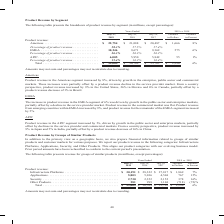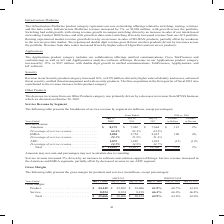From Cisco Systems's financial document, Which categories does the company report its product revenue? The document contains multiple relevant values: Infrastructure Platforms, Applications, Security, Other Products. From the document: "our product revenue in the following categories: Infrastructure Platforms, Applications, Security, and Other Products. This aligns our product categor..." Also, What was the revenue from Security in 2019? According to the financial document, 2,730 (in millions). The relevant text states: "plications . 5,803 5,036 4,568 767 15% Security . 2,730 2,352 2,152 378 16% Other Products . 281 999 1,168 (718) (72)% Total . $ 39,005 $ 36,709 $ 35,705 $..." Also, What was the revenue from Other products in 2018? According to the financial document, 999 (in millions). The relevant text states: ". 2,730 2,352 2,152 378 16% Other Products . 281 999 1,168 (718) (72)% Total . $ 39,005 $ 36,709 $ 35,705 $ 2,296 6%..." Also, can you calculate: What was the change in revenue from security between 2017 and 2018? Based on the calculation: 2,352-2,152, the result is 200 (in millions). This is based on the information: "5,803 5,036 4,568 767 15% Security . 2,730 2,352 2,152 378 16% Other Products . 281 999 1,168 (718) (72)% Total . $ 39,005 $ 36,709 $ 35,705 $ 2,296 6% ions . 5,803 5,036 4,568 767 15% Security . 2,73..." The key data points involved are: 2,152, 2,352. Also, How many years did revenue from infrastructure platforms exceed $30,000 million? Based on the analysis, there are 1 instances. The counting process: 2019. Also, can you calculate: What was the percentage change in total revenue between 2017 and 2018? To answer this question, I need to perform calculations using the financial data. The calculation is: (36,709-35,705)/35,705, which equals 2.81 (percentage). This is based on the information: "ct revenue . 15.4% 16.2% 16.4% Total . $ 39,005 $ 36,709 $ 35,705 $ 2,296 6% e . 15.4% 16.2% 16.4% Total . $ 39,005 $ 36,709 $ 35,705 $ 2,296 6%..." The key data points involved are: 35,705, 36,709. 